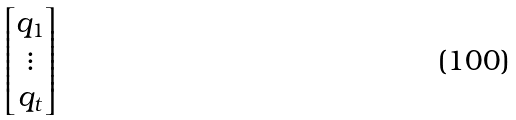Convert formula to latex. <formula><loc_0><loc_0><loc_500><loc_500>\begin{bmatrix} q _ { 1 } \\ \vdots \\ q _ { t } \end{bmatrix}</formula> 